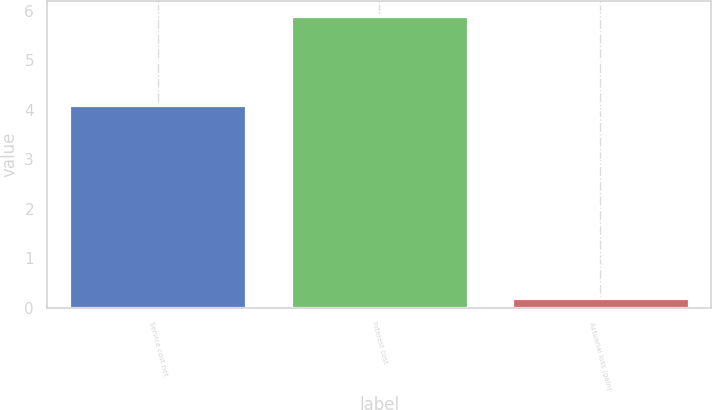Convert chart to OTSL. <chart><loc_0><loc_0><loc_500><loc_500><bar_chart><fcel>Service cost net<fcel>Interest cost<fcel>Actuarial loss (gain)<nl><fcel>4.1<fcel>5.9<fcel>0.2<nl></chart> 